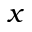<formula> <loc_0><loc_0><loc_500><loc_500>x</formula> 